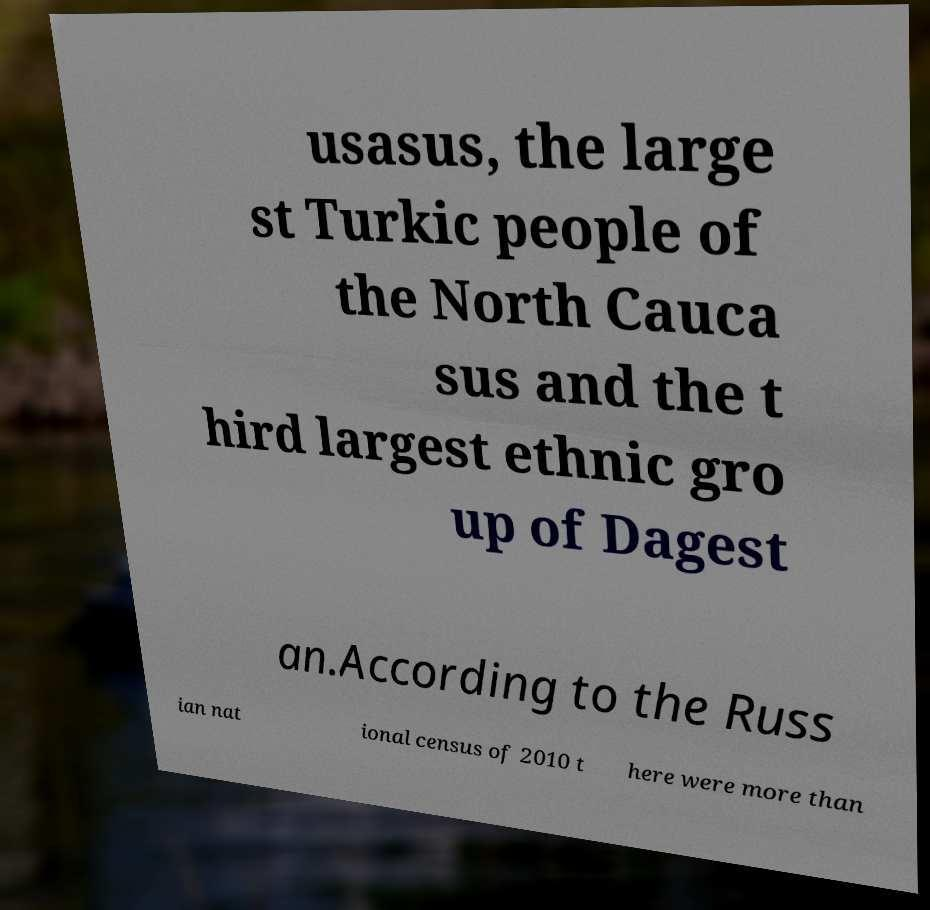Can you read and provide the text displayed in the image?This photo seems to have some interesting text. Can you extract and type it out for me? usasus, the large st Turkic people of the North Cauca sus and the t hird largest ethnic gro up of Dagest an.According to the Russ ian nat ional census of 2010 t here were more than 